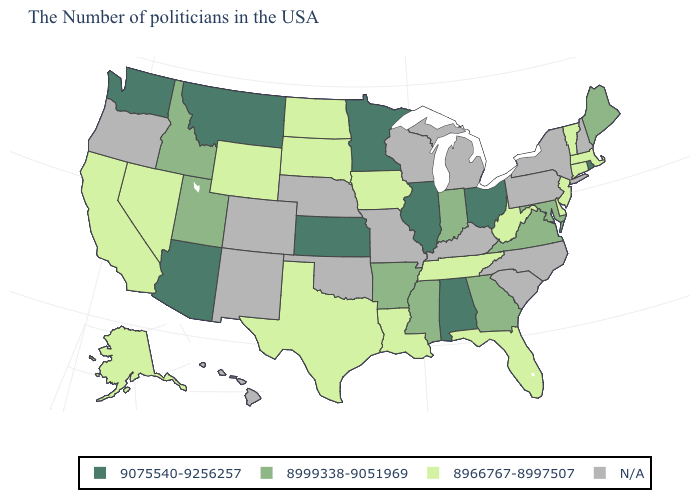Does Alabama have the highest value in the South?
Quick response, please. Yes. Name the states that have a value in the range 8999338-9051969?
Answer briefly. Maine, Maryland, Virginia, Georgia, Indiana, Mississippi, Arkansas, Utah, Idaho. What is the highest value in the USA?
Keep it brief. 9075540-9256257. Name the states that have a value in the range 9075540-9256257?
Concise answer only. Rhode Island, Ohio, Alabama, Illinois, Minnesota, Kansas, Montana, Arizona, Washington. What is the lowest value in the MidWest?
Be succinct. 8966767-8997507. Name the states that have a value in the range N/A?
Keep it brief. New Hampshire, New York, Pennsylvania, North Carolina, South Carolina, Michigan, Kentucky, Wisconsin, Missouri, Nebraska, Oklahoma, Colorado, New Mexico, Oregon, Hawaii. Name the states that have a value in the range 8999338-9051969?
Give a very brief answer. Maine, Maryland, Virginia, Georgia, Indiana, Mississippi, Arkansas, Utah, Idaho. Does the map have missing data?
Give a very brief answer. Yes. Name the states that have a value in the range N/A?
Write a very short answer. New Hampshire, New York, Pennsylvania, North Carolina, South Carolina, Michigan, Kentucky, Wisconsin, Missouri, Nebraska, Oklahoma, Colorado, New Mexico, Oregon, Hawaii. Which states have the lowest value in the South?
Keep it brief. Delaware, West Virginia, Florida, Tennessee, Louisiana, Texas. Name the states that have a value in the range 8999338-9051969?
Concise answer only. Maine, Maryland, Virginia, Georgia, Indiana, Mississippi, Arkansas, Utah, Idaho. Name the states that have a value in the range 8966767-8997507?
Write a very short answer. Massachusetts, Vermont, Connecticut, New Jersey, Delaware, West Virginia, Florida, Tennessee, Louisiana, Iowa, Texas, South Dakota, North Dakota, Wyoming, Nevada, California, Alaska. Name the states that have a value in the range 8966767-8997507?
Concise answer only. Massachusetts, Vermont, Connecticut, New Jersey, Delaware, West Virginia, Florida, Tennessee, Louisiana, Iowa, Texas, South Dakota, North Dakota, Wyoming, Nevada, California, Alaska. Name the states that have a value in the range N/A?
Write a very short answer. New Hampshire, New York, Pennsylvania, North Carolina, South Carolina, Michigan, Kentucky, Wisconsin, Missouri, Nebraska, Oklahoma, Colorado, New Mexico, Oregon, Hawaii. 